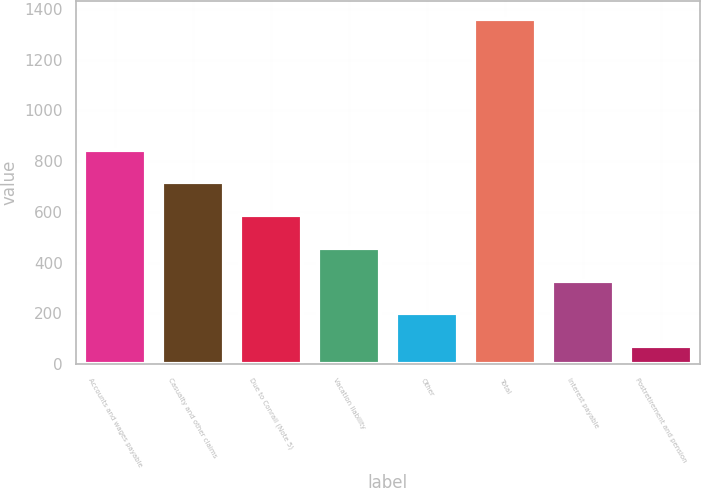Convert chart. <chart><loc_0><loc_0><loc_500><loc_500><bar_chart><fcel>Accounts and wages payable<fcel>Casualty and other claims<fcel>Due to Conrail (Note 5)<fcel>Vacation liability<fcel>Other<fcel>Total<fcel>Interest payable<fcel>Postretirement and pension<nl><fcel>845.2<fcel>716<fcel>586.8<fcel>457.6<fcel>199.2<fcel>1362<fcel>328.4<fcel>70<nl></chart> 